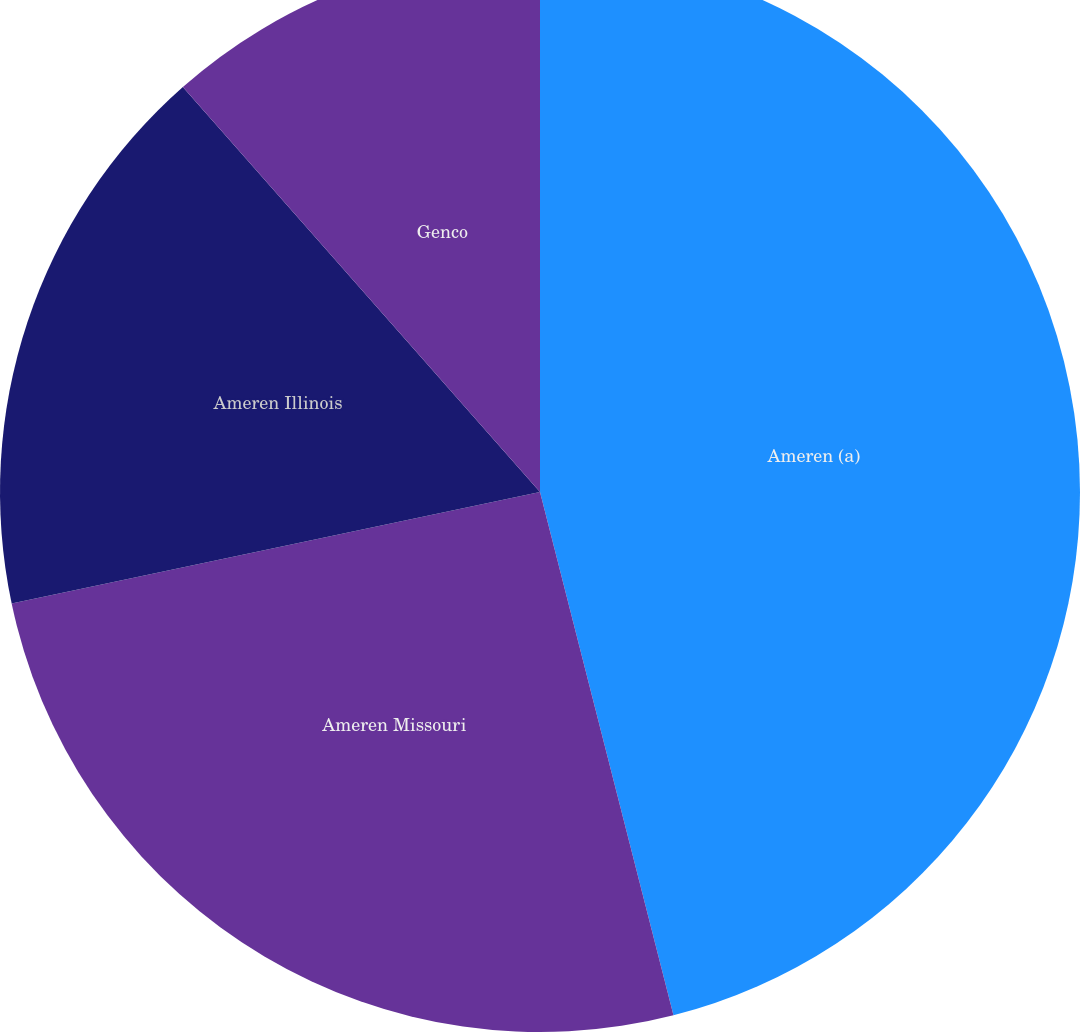Convert chart to OTSL. <chart><loc_0><loc_0><loc_500><loc_500><pie_chart><fcel>Ameren (a)<fcel>Ameren Missouri<fcel>Ameren Illinois<fcel>Genco<nl><fcel>46.02%<fcel>25.66%<fcel>16.81%<fcel>11.5%<nl></chart> 